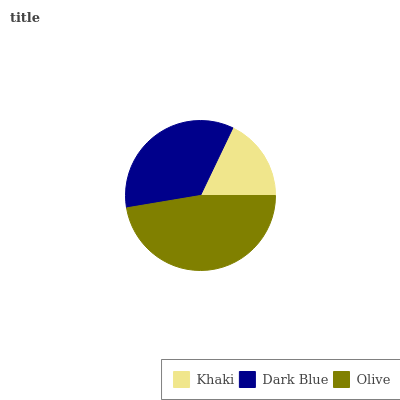Is Khaki the minimum?
Answer yes or no. Yes. Is Olive the maximum?
Answer yes or no. Yes. Is Dark Blue the minimum?
Answer yes or no. No. Is Dark Blue the maximum?
Answer yes or no. No. Is Dark Blue greater than Khaki?
Answer yes or no. Yes. Is Khaki less than Dark Blue?
Answer yes or no. Yes. Is Khaki greater than Dark Blue?
Answer yes or no. No. Is Dark Blue less than Khaki?
Answer yes or no. No. Is Dark Blue the high median?
Answer yes or no. Yes. Is Dark Blue the low median?
Answer yes or no. Yes. Is Khaki the high median?
Answer yes or no. No. Is Khaki the low median?
Answer yes or no. No. 